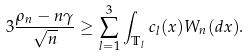Convert formula to latex. <formula><loc_0><loc_0><loc_500><loc_500>3 \frac { \rho _ { n } - n \gamma } { \sqrt { n } } \geq \sum _ { l = 1 } ^ { 3 } \int _ { \mathbb { T } _ { l } } c _ { l } ( x ) W _ { n } ( d x ) .</formula> 